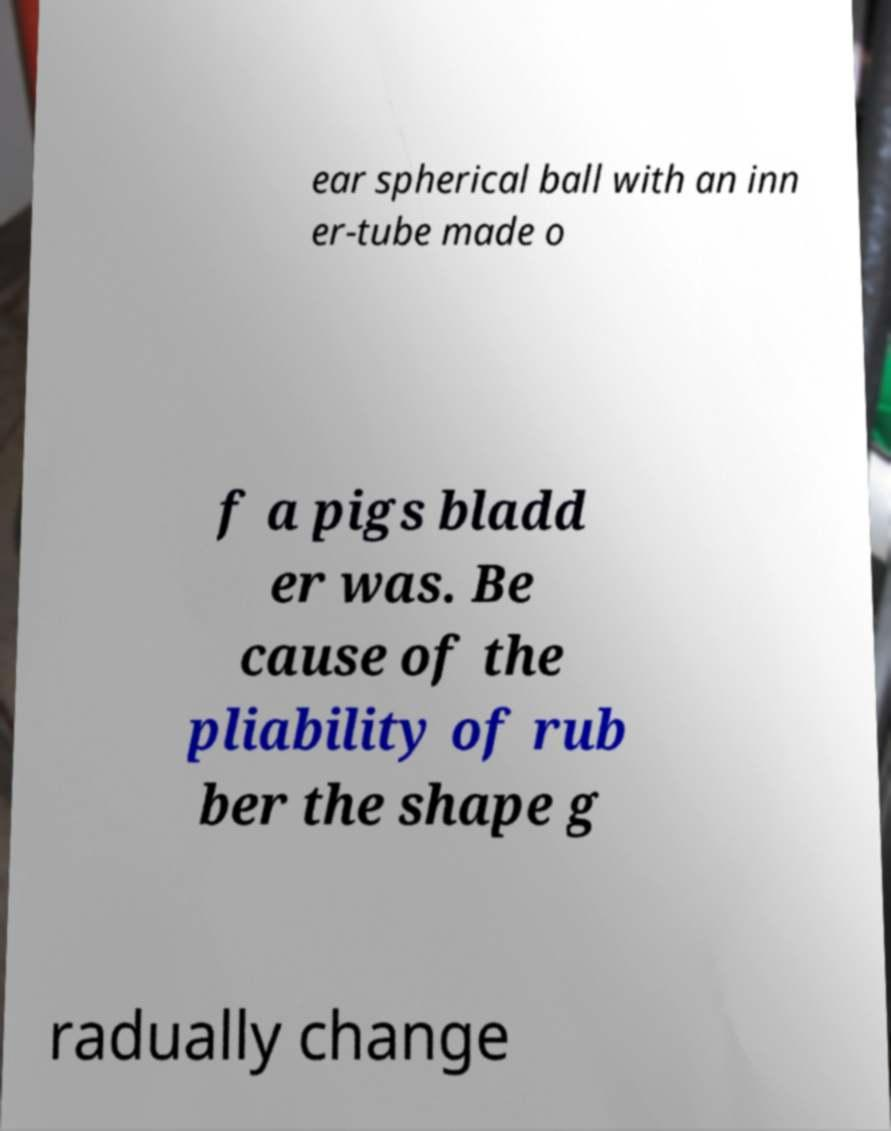Please read and relay the text visible in this image. What does it say? ear spherical ball with an inn er-tube made o f a pigs bladd er was. Be cause of the pliability of rub ber the shape g radually change 